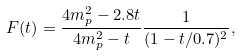Convert formula to latex. <formula><loc_0><loc_0><loc_500><loc_500>F ( t ) = \frac { 4 m ^ { 2 } _ { p } - 2 . 8 t } { 4 m ^ { 2 } _ { p } - t } \frac { 1 } { ( 1 - t / 0 . 7 ) ^ { 2 } } ,</formula> 